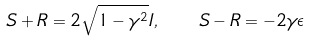Convert formula to latex. <formula><loc_0><loc_0><loc_500><loc_500>S + R = 2 \sqrt { 1 - \gamma ^ { 2 } } I , \quad S - R = - 2 \gamma \epsilon</formula> 